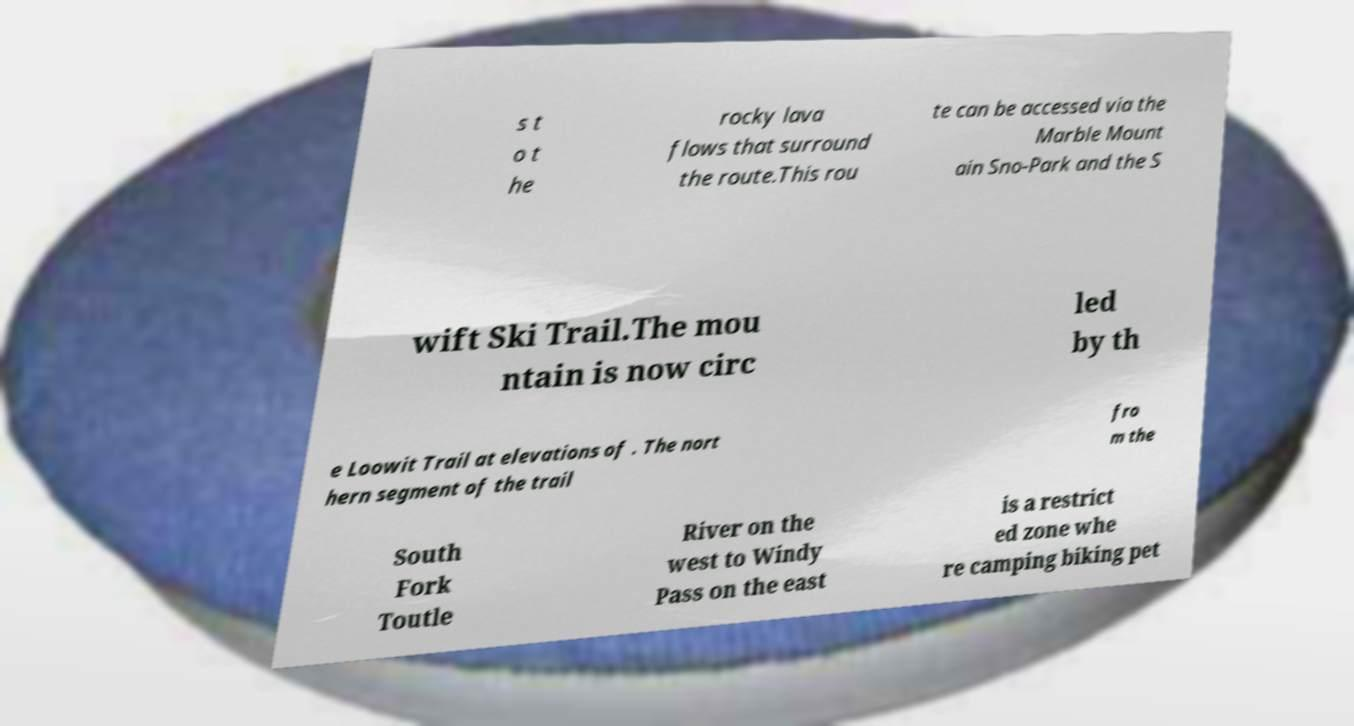I need the written content from this picture converted into text. Can you do that? s t o t he rocky lava flows that surround the route.This rou te can be accessed via the Marble Mount ain Sno-Park and the S wift Ski Trail.The mou ntain is now circ led by th e Loowit Trail at elevations of . The nort hern segment of the trail fro m the South Fork Toutle River on the west to Windy Pass on the east is a restrict ed zone whe re camping biking pet 